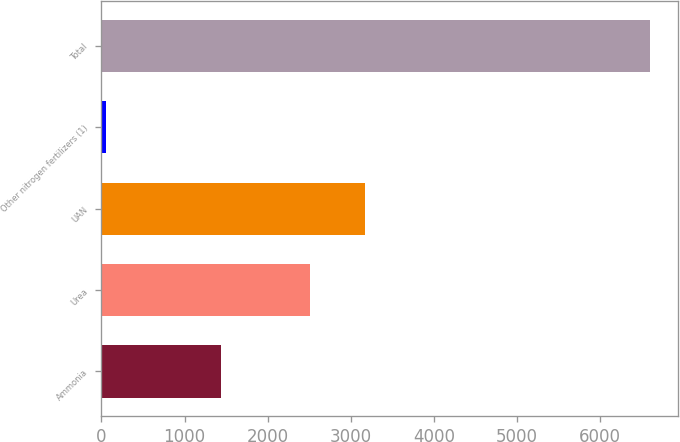Convert chart. <chart><loc_0><loc_0><loc_500><loc_500><bar_chart><fcel>Ammonia<fcel>Urea<fcel>UAN<fcel>Other nitrogen fertilizers (1)<fcel>Total<nl><fcel>1438<fcel>2513<fcel>3167.4<fcel>59<fcel>6603<nl></chart> 